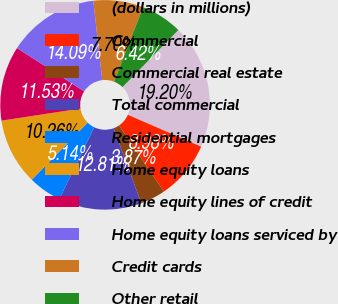Convert chart to OTSL. <chart><loc_0><loc_0><loc_500><loc_500><pie_chart><fcel>(dollars in millions)<fcel>Commercial<fcel>Commercial real estate<fcel>Total commercial<fcel>Residential mortgages<fcel>Home equity loans<fcel>Home equity lines of credit<fcel>Home equity loans serviced by<fcel>Credit cards<fcel>Other retail<nl><fcel>19.2%<fcel>8.98%<fcel>3.87%<fcel>12.81%<fcel>5.14%<fcel>10.26%<fcel>11.53%<fcel>14.09%<fcel>7.7%<fcel>6.42%<nl></chart> 